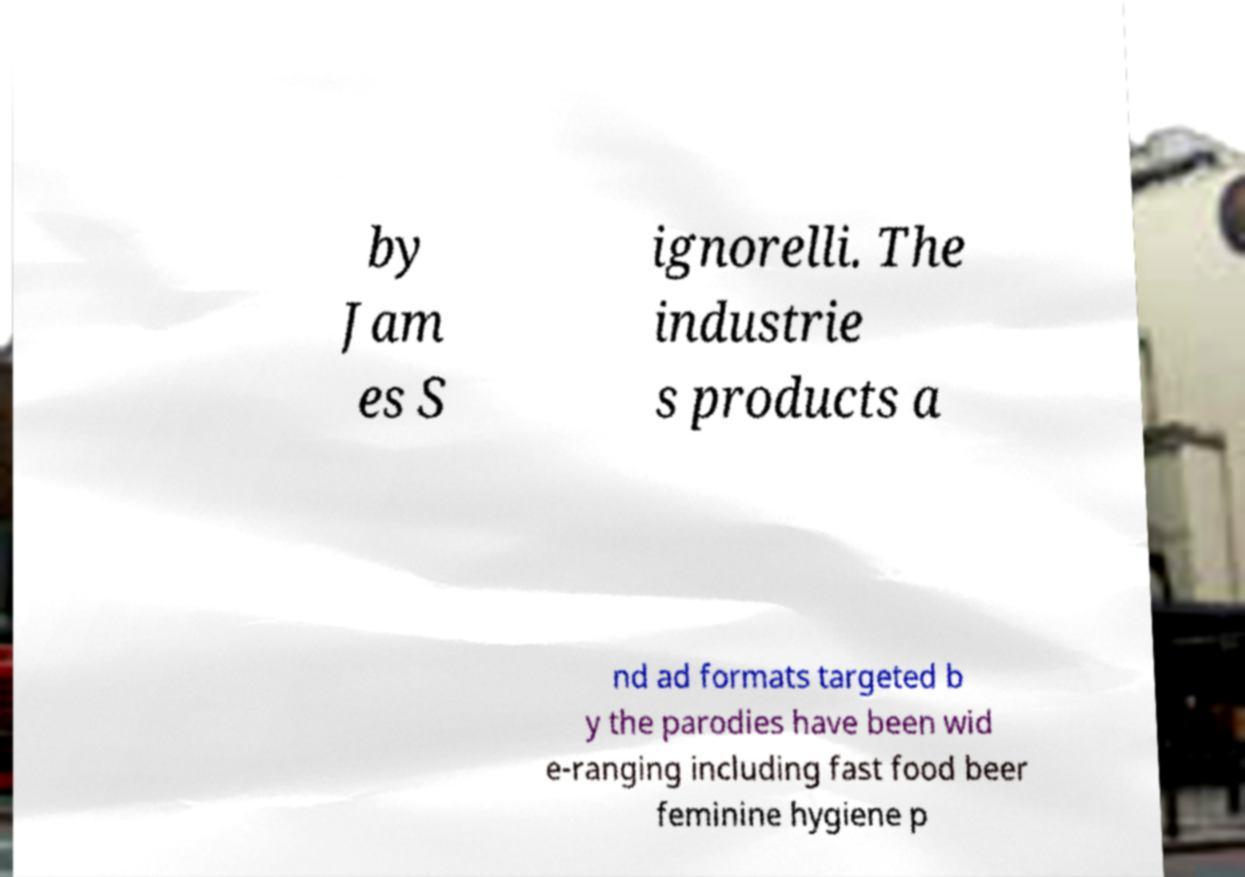What messages or text are displayed in this image? I need them in a readable, typed format. by Jam es S ignorelli. The industrie s products a nd ad formats targeted b y the parodies have been wid e-ranging including fast food beer feminine hygiene p 